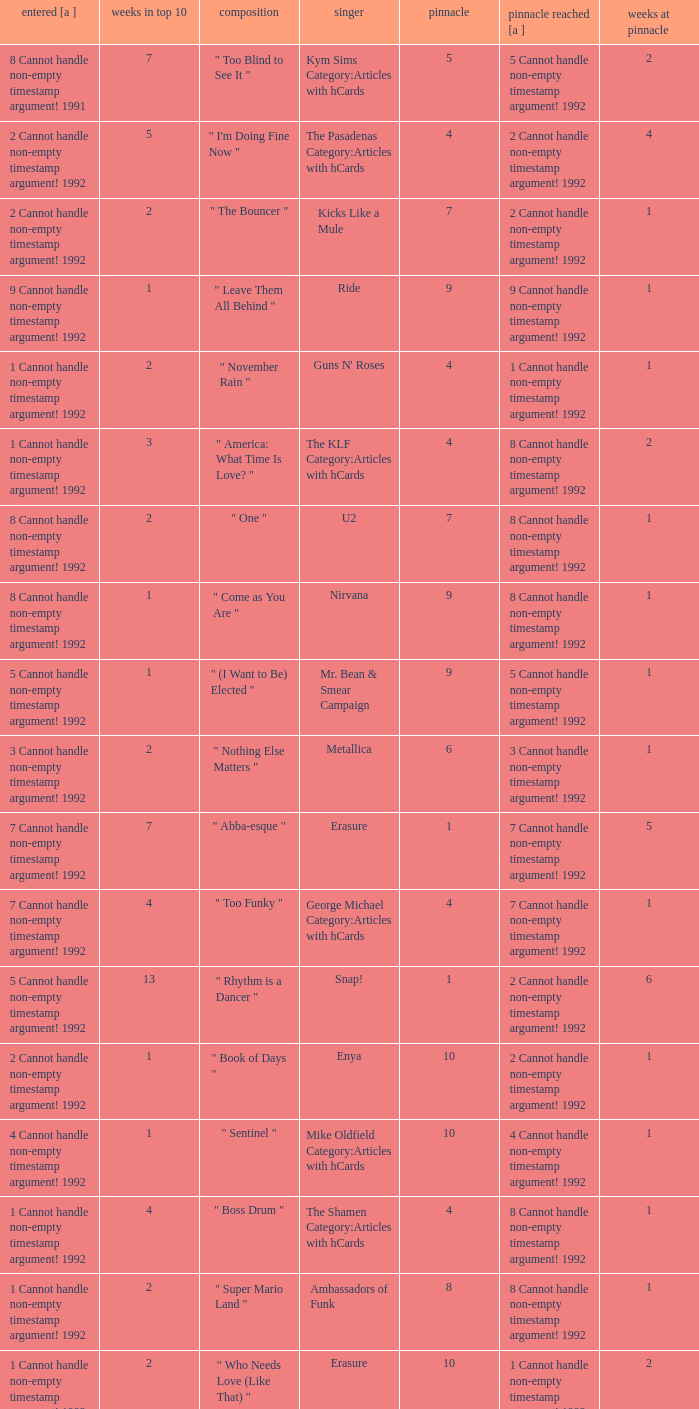If the peak is 9, how many weeks was it in the top 10? 1.0. 